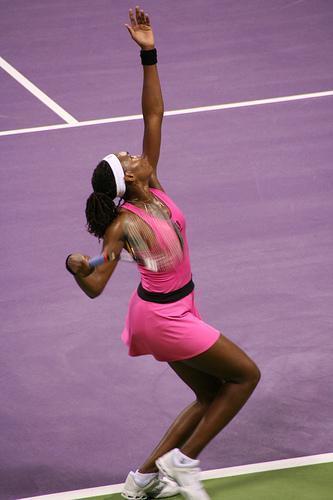How many people was shown?
Give a very brief answer. 1. 